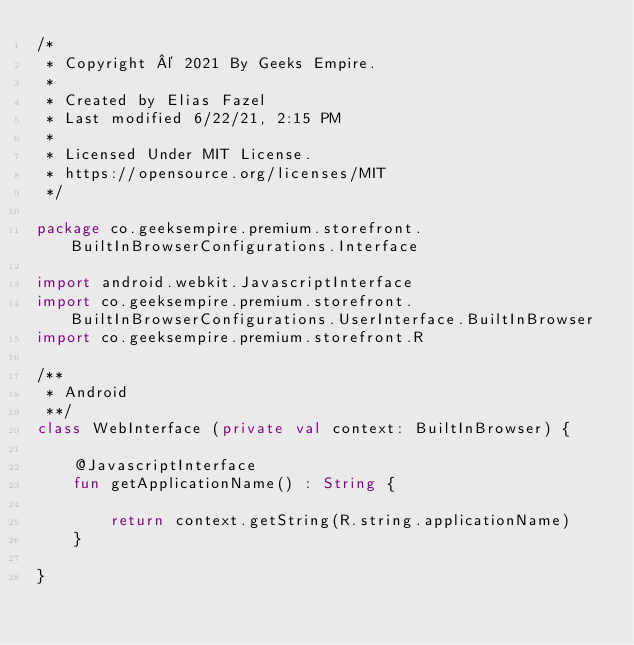Convert code to text. <code><loc_0><loc_0><loc_500><loc_500><_Kotlin_>/*
 * Copyright © 2021 By Geeks Empire.
 *
 * Created by Elias Fazel
 * Last modified 6/22/21, 2:15 PM
 *
 * Licensed Under MIT License.
 * https://opensource.org/licenses/MIT
 */

package co.geeksempire.premium.storefront.BuiltInBrowserConfigurations.Interface

import android.webkit.JavascriptInterface
import co.geeksempire.premium.storefront.BuiltInBrowserConfigurations.UserInterface.BuiltInBrowser
import co.geeksempire.premium.storefront.R

/**
 * Android
 **/
class WebInterface (private val context: BuiltInBrowser) {

    @JavascriptInterface
    fun getApplicationName() : String {

        return context.getString(R.string.applicationName)
    }

}</code> 